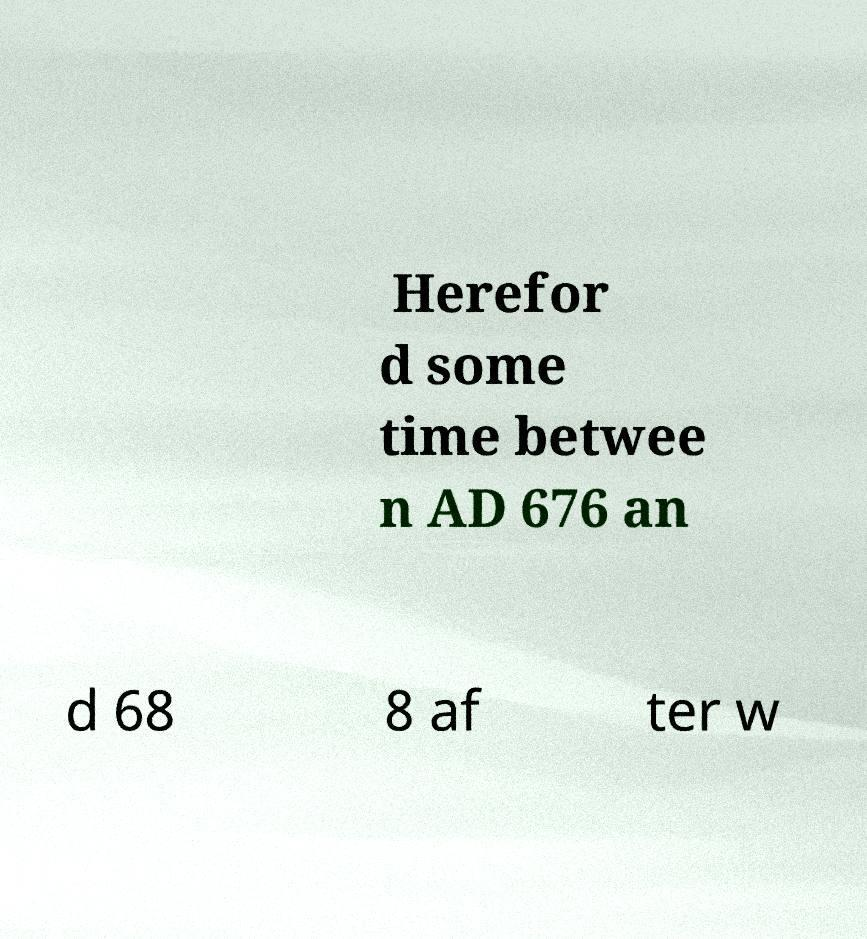I need the written content from this picture converted into text. Can you do that? Herefor d some time betwee n AD 676 an d 68 8 af ter w 